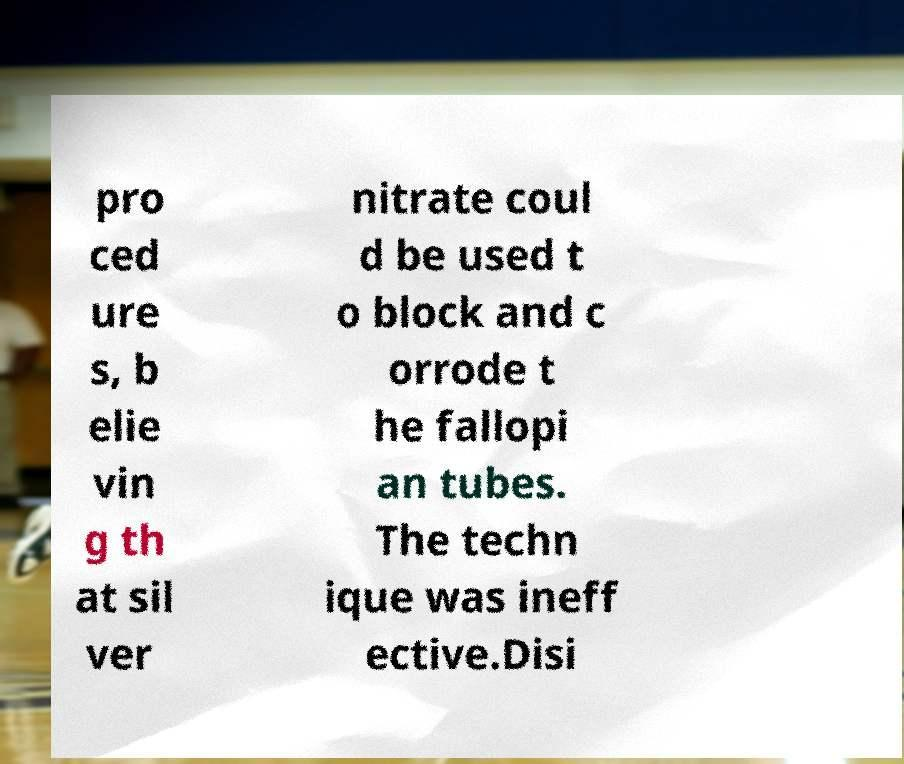For documentation purposes, I need the text within this image transcribed. Could you provide that? pro ced ure s, b elie vin g th at sil ver nitrate coul d be used t o block and c orrode t he fallopi an tubes. The techn ique was ineff ective.Disi 